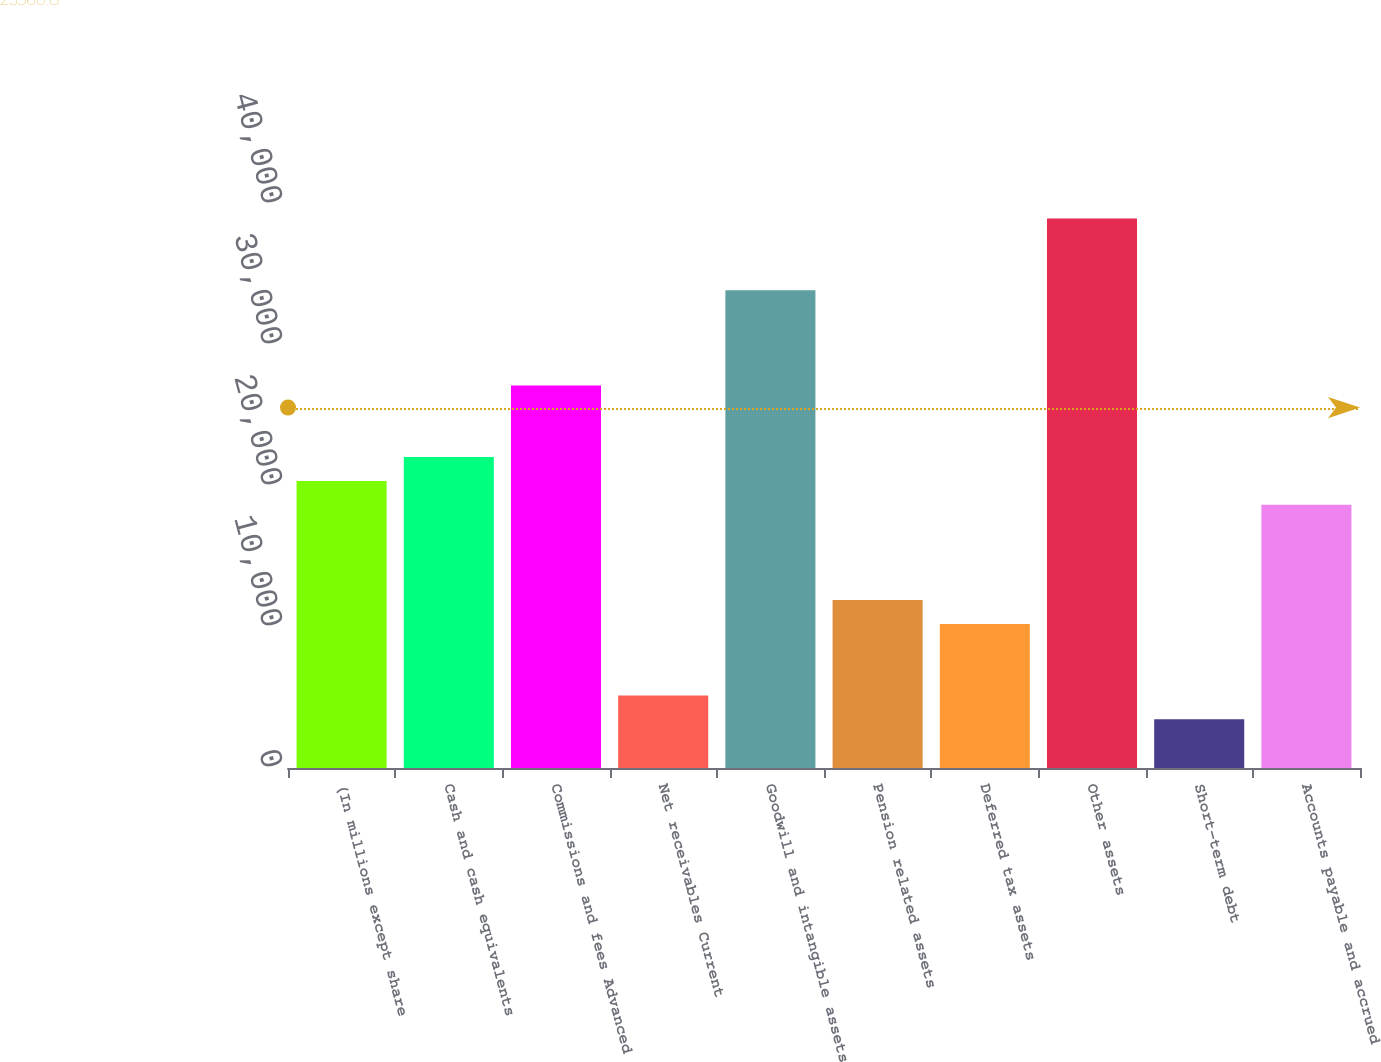<chart> <loc_0><loc_0><loc_500><loc_500><bar_chart><fcel>(In millions except share<fcel>Cash and cash equivalents<fcel>Commissions and fees Advanced<fcel>Net receivables Current<fcel>Goodwill and intangible assets<fcel>Pension related assets<fcel>Deferred tax assets<fcel>Other assets<fcel>Short-term debt<fcel>Accounts payable and accrued<nl><fcel>20362<fcel>22053<fcel>27126<fcel>5143<fcel>33890<fcel>11907<fcel>10216<fcel>38963<fcel>3452<fcel>18671<nl></chart> 